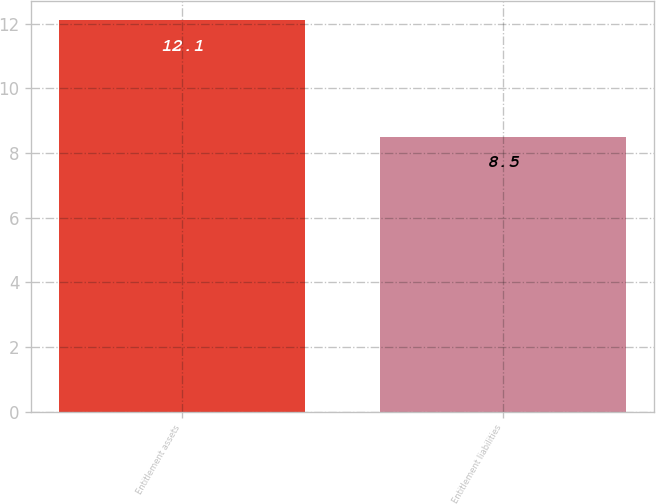<chart> <loc_0><loc_0><loc_500><loc_500><bar_chart><fcel>Entitlement assets<fcel>Entitlement liabilities<nl><fcel>12.1<fcel>8.5<nl></chart> 